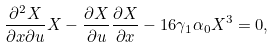<formula> <loc_0><loc_0><loc_500><loc_500>\frac { \partial ^ { 2 } X } { \partial x \partial u } X - \frac { \partial X } { \partial u } \frac { \partial X } { \partial x } - 1 6 \gamma _ { 1 } \alpha _ { 0 } X ^ { 3 } = 0 ,</formula> 